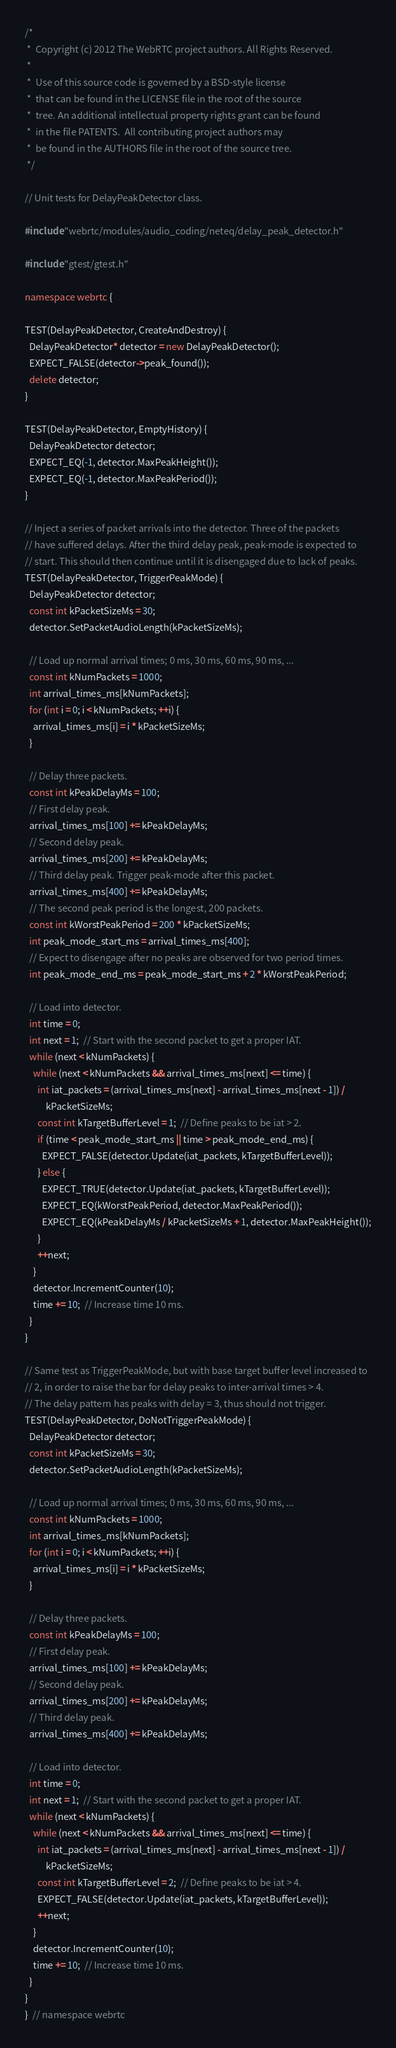<code> <loc_0><loc_0><loc_500><loc_500><_C++_>/*
 *  Copyright (c) 2012 The WebRTC project authors. All Rights Reserved.
 *
 *  Use of this source code is governed by a BSD-style license
 *  that can be found in the LICENSE file in the root of the source
 *  tree. An additional intellectual property rights grant can be found
 *  in the file PATENTS.  All contributing project authors may
 *  be found in the AUTHORS file in the root of the source tree.
 */

// Unit tests for DelayPeakDetector class.

#include "webrtc/modules/audio_coding/neteq/delay_peak_detector.h"

#include "gtest/gtest.h"

namespace webrtc {

TEST(DelayPeakDetector, CreateAndDestroy) {
  DelayPeakDetector* detector = new DelayPeakDetector();
  EXPECT_FALSE(detector->peak_found());
  delete detector;
}

TEST(DelayPeakDetector, EmptyHistory) {
  DelayPeakDetector detector;
  EXPECT_EQ(-1, detector.MaxPeakHeight());
  EXPECT_EQ(-1, detector.MaxPeakPeriod());
}

// Inject a series of packet arrivals into the detector. Three of the packets
// have suffered delays. After the third delay peak, peak-mode is expected to
// start. This should then continue until it is disengaged due to lack of peaks.
TEST(DelayPeakDetector, TriggerPeakMode) {
  DelayPeakDetector detector;
  const int kPacketSizeMs = 30;
  detector.SetPacketAudioLength(kPacketSizeMs);

  // Load up normal arrival times; 0 ms, 30 ms, 60 ms, 90 ms, ...
  const int kNumPackets = 1000;
  int arrival_times_ms[kNumPackets];
  for (int i = 0; i < kNumPackets; ++i) {
    arrival_times_ms[i] = i * kPacketSizeMs;
  }

  // Delay three packets.
  const int kPeakDelayMs = 100;
  // First delay peak.
  arrival_times_ms[100] += kPeakDelayMs;
  // Second delay peak.
  arrival_times_ms[200] += kPeakDelayMs;
  // Third delay peak. Trigger peak-mode after this packet.
  arrival_times_ms[400] += kPeakDelayMs;
  // The second peak period is the longest, 200 packets.
  const int kWorstPeakPeriod = 200 * kPacketSizeMs;
  int peak_mode_start_ms = arrival_times_ms[400];
  // Expect to disengage after no peaks are observed for two period times.
  int peak_mode_end_ms = peak_mode_start_ms + 2 * kWorstPeakPeriod;

  // Load into detector.
  int time = 0;
  int next = 1;  // Start with the second packet to get a proper IAT.
  while (next < kNumPackets) {
    while (next < kNumPackets && arrival_times_ms[next] <= time) {
      int iat_packets = (arrival_times_ms[next] - arrival_times_ms[next - 1]) /
          kPacketSizeMs;
      const int kTargetBufferLevel = 1;  // Define peaks to be iat > 2.
      if (time < peak_mode_start_ms || time > peak_mode_end_ms) {
        EXPECT_FALSE(detector.Update(iat_packets, kTargetBufferLevel));
      } else {
        EXPECT_TRUE(detector.Update(iat_packets, kTargetBufferLevel));
        EXPECT_EQ(kWorstPeakPeriod, detector.MaxPeakPeriod());
        EXPECT_EQ(kPeakDelayMs / kPacketSizeMs + 1, detector.MaxPeakHeight());
      }
      ++next;
    }
    detector.IncrementCounter(10);
    time += 10;  // Increase time 10 ms.
  }
}

// Same test as TriggerPeakMode, but with base target buffer level increased to
// 2, in order to raise the bar for delay peaks to inter-arrival times > 4.
// The delay pattern has peaks with delay = 3, thus should not trigger.
TEST(DelayPeakDetector, DoNotTriggerPeakMode) {
  DelayPeakDetector detector;
  const int kPacketSizeMs = 30;
  detector.SetPacketAudioLength(kPacketSizeMs);

  // Load up normal arrival times; 0 ms, 30 ms, 60 ms, 90 ms, ...
  const int kNumPackets = 1000;
  int arrival_times_ms[kNumPackets];
  for (int i = 0; i < kNumPackets; ++i) {
    arrival_times_ms[i] = i * kPacketSizeMs;
  }

  // Delay three packets.
  const int kPeakDelayMs = 100;
  // First delay peak.
  arrival_times_ms[100] += kPeakDelayMs;
  // Second delay peak.
  arrival_times_ms[200] += kPeakDelayMs;
  // Third delay peak.
  arrival_times_ms[400] += kPeakDelayMs;

  // Load into detector.
  int time = 0;
  int next = 1;  // Start with the second packet to get a proper IAT.
  while (next < kNumPackets) {
    while (next < kNumPackets && arrival_times_ms[next] <= time) {
      int iat_packets = (arrival_times_ms[next] - arrival_times_ms[next - 1]) /
          kPacketSizeMs;
      const int kTargetBufferLevel = 2;  // Define peaks to be iat > 4.
      EXPECT_FALSE(detector.Update(iat_packets, kTargetBufferLevel));
      ++next;
    }
    detector.IncrementCounter(10);
    time += 10;  // Increase time 10 ms.
  }
}
}  // namespace webrtc
</code> 